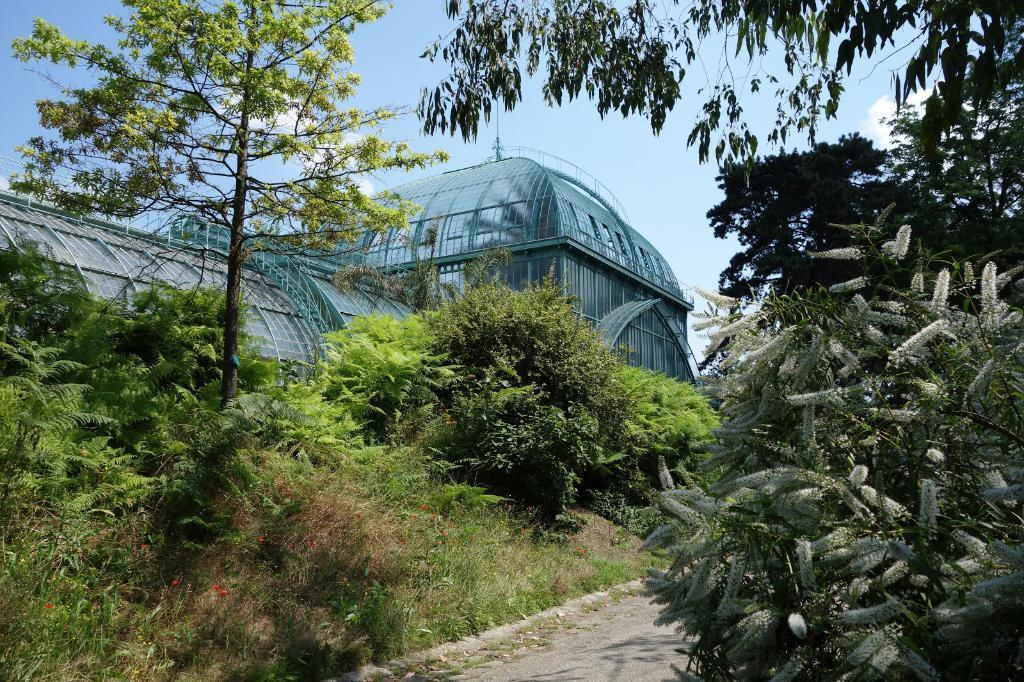What is located in the middle of the image? There are plants, trees, grass, and a road in the middle of the image. Can you describe the vegetation in the image? The image contains plants and trees, as well as grass. What is visible at the top of the image? There is a building, sky, and clouds visible at the top of the image. Is there a locket hanging from the tree in the image? There is no locket present in the image; it only contains plants, trees, grass, a road, a building, sky, and clouds. What type of agreement is being made between the plants and the trees in the image? There is no agreement being made between the plants and the trees in the image, as they are inanimate objects. 